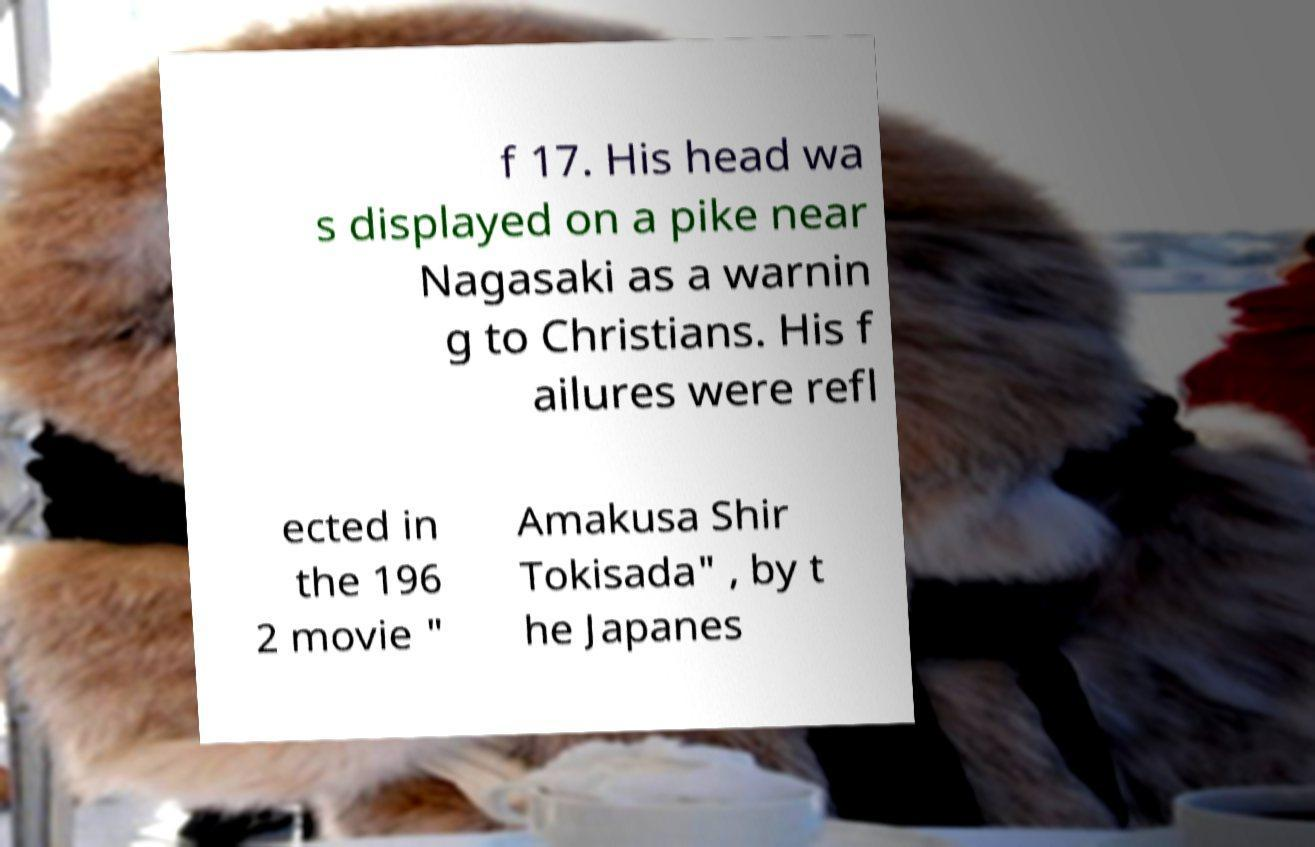Please identify and transcribe the text found in this image. f 17. His head wa s displayed on a pike near Nagasaki as a warnin g to Christians. His f ailures were refl ected in the 196 2 movie " Amakusa Shir Tokisada" , by t he Japanes 